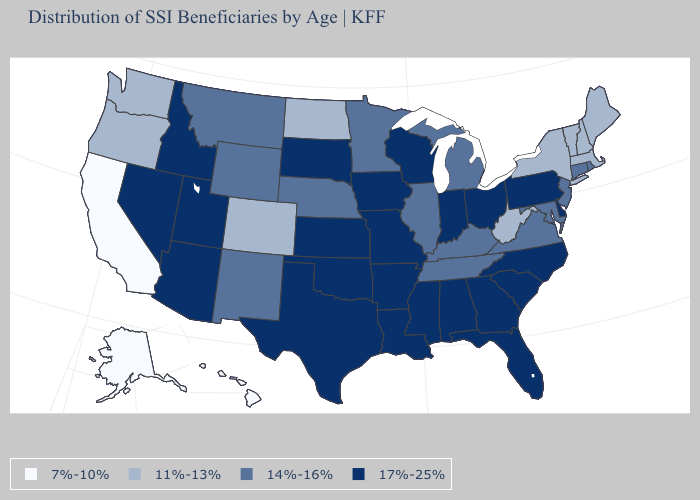Name the states that have a value in the range 7%-10%?
Keep it brief. Alaska, California, Hawaii. What is the highest value in the South ?
Write a very short answer. 17%-25%. What is the value of Oklahoma?
Quick response, please. 17%-25%. What is the value of Oklahoma?
Short answer required. 17%-25%. Name the states that have a value in the range 17%-25%?
Short answer required. Alabama, Arizona, Arkansas, Delaware, Florida, Georgia, Idaho, Indiana, Iowa, Kansas, Louisiana, Mississippi, Missouri, Nevada, North Carolina, Ohio, Oklahoma, Pennsylvania, South Carolina, South Dakota, Texas, Utah, Wisconsin. Name the states that have a value in the range 17%-25%?
Answer briefly. Alabama, Arizona, Arkansas, Delaware, Florida, Georgia, Idaho, Indiana, Iowa, Kansas, Louisiana, Mississippi, Missouri, Nevada, North Carolina, Ohio, Oklahoma, Pennsylvania, South Carolina, South Dakota, Texas, Utah, Wisconsin. Among the states that border New Mexico , does Colorado have the highest value?
Be succinct. No. Is the legend a continuous bar?
Give a very brief answer. No. Does the map have missing data?
Keep it brief. No. Name the states that have a value in the range 11%-13%?
Answer briefly. Colorado, Maine, Massachusetts, New Hampshire, New York, North Dakota, Oregon, Vermont, Washington, West Virginia. What is the value of Idaho?
Quick response, please. 17%-25%. Does Massachusetts have the highest value in the USA?
Short answer required. No. Name the states that have a value in the range 11%-13%?
Quick response, please. Colorado, Maine, Massachusetts, New Hampshire, New York, North Dakota, Oregon, Vermont, Washington, West Virginia. What is the lowest value in the Northeast?
Write a very short answer. 11%-13%. Which states have the lowest value in the USA?
Keep it brief. Alaska, California, Hawaii. 